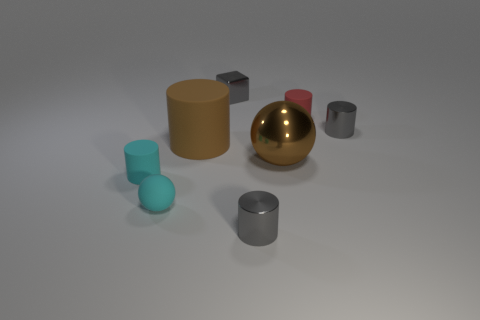Subtract all cyan rubber cylinders. How many cylinders are left? 4 Subtract all cyan balls. How many balls are left? 1 Add 8 large matte cylinders. How many large matte cylinders are left? 9 Add 2 cyan balls. How many cyan balls exist? 3 Add 1 cyan rubber things. How many objects exist? 9 Subtract 0 red cubes. How many objects are left? 8 Subtract all spheres. How many objects are left? 6 Subtract 1 cylinders. How many cylinders are left? 4 Subtract all green spheres. Subtract all gray blocks. How many spheres are left? 2 Subtract all green cubes. How many cyan spheres are left? 1 